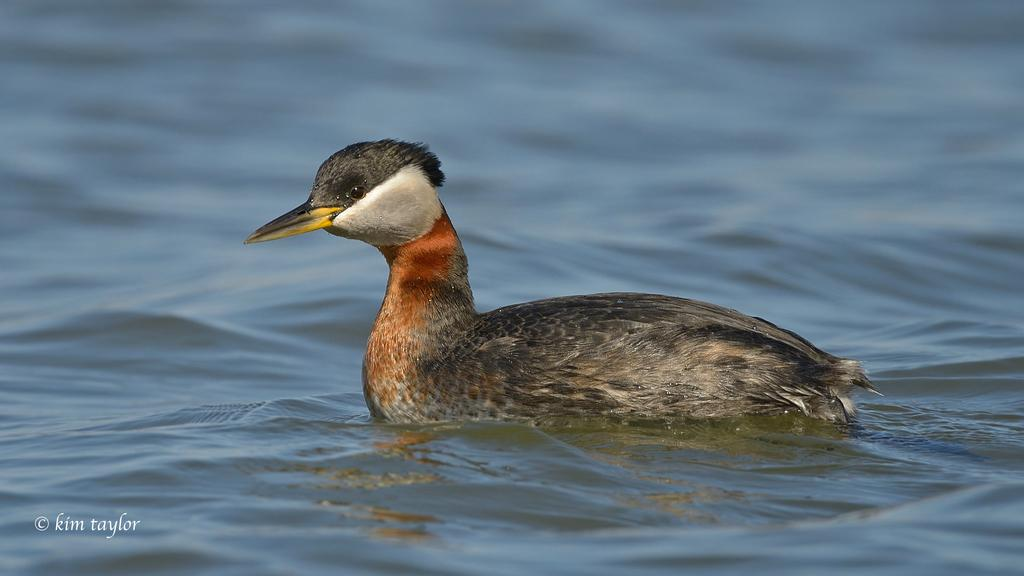What type of animal is in the image? There is a mallard in the image. What is the primary element surrounding the mallard? There is water visible in the image. Can you describe any additional features of the image? There is a watermark in the bottom left corner of the image. What type of shop can be seen in the background of the image? There is no shop visible in the image; it features a mallard in water with a watermark in the corner. 